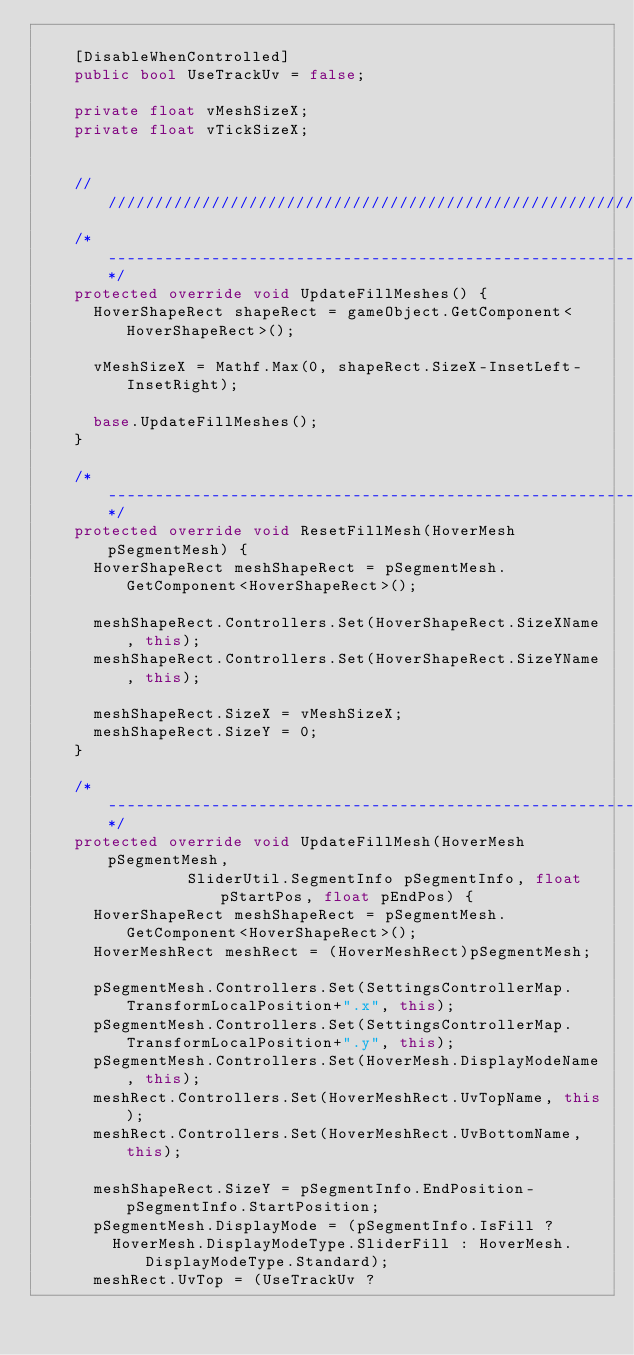Convert code to text. <code><loc_0><loc_0><loc_500><loc_500><_C#_>
		[DisableWhenControlled]
		public bool UseTrackUv = false;

		private float vMeshSizeX;
		private float vTickSizeX;


		////////////////////////////////////////////////////////////////////////////////////////////////
		/*--------------------------------------------------------------------------------------------*/
		protected override void UpdateFillMeshes() {
			HoverShapeRect shapeRect = gameObject.GetComponent<HoverShapeRect>();

			vMeshSizeX = Mathf.Max(0, shapeRect.SizeX-InsetLeft-InsetRight);

			base.UpdateFillMeshes();
		}

		/*--------------------------------------------------------------------------------------------*/
		protected override void ResetFillMesh(HoverMesh pSegmentMesh) {
			HoverShapeRect meshShapeRect = pSegmentMesh.GetComponent<HoverShapeRect>();

			meshShapeRect.Controllers.Set(HoverShapeRect.SizeXName, this);
			meshShapeRect.Controllers.Set(HoverShapeRect.SizeYName, this);

			meshShapeRect.SizeX = vMeshSizeX;
			meshShapeRect.SizeY = 0;
		}

		/*--------------------------------------------------------------------------------------------*/
		protected override void UpdateFillMesh(HoverMesh pSegmentMesh, 
								SliderUtil.SegmentInfo pSegmentInfo, float pStartPos, float pEndPos) {
			HoverShapeRect meshShapeRect = pSegmentMesh.GetComponent<HoverShapeRect>();
			HoverMeshRect meshRect = (HoverMeshRect)pSegmentMesh;
			
			pSegmentMesh.Controllers.Set(SettingsControllerMap.TransformLocalPosition+".x", this);
			pSegmentMesh.Controllers.Set(SettingsControllerMap.TransformLocalPosition+".y", this);
			pSegmentMesh.Controllers.Set(HoverMesh.DisplayModeName, this);
			meshRect.Controllers.Set(HoverMeshRect.UvTopName, this);
			meshRect.Controllers.Set(HoverMeshRect.UvBottomName, this);

			meshShapeRect.SizeY = pSegmentInfo.EndPosition-pSegmentInfo.StartPosition;
			pSegmentMesh.DisplayMode = (pSegmentInfo.IsFill ?
				HoverMesh.DisplayModeType.SliderFill : HoverMesh.DisplayModeType.Standard);
			meshRect.UvTop = (UseTrackUv ?</code> 